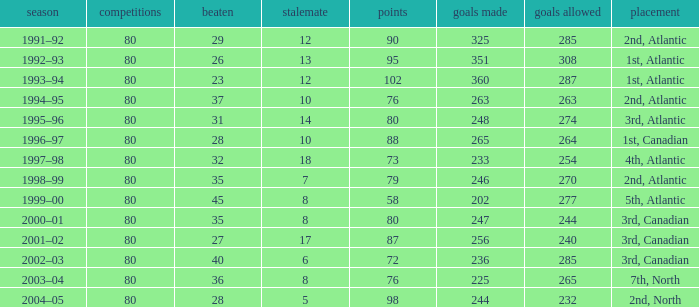How many goals against have 58 points? 277.0. 